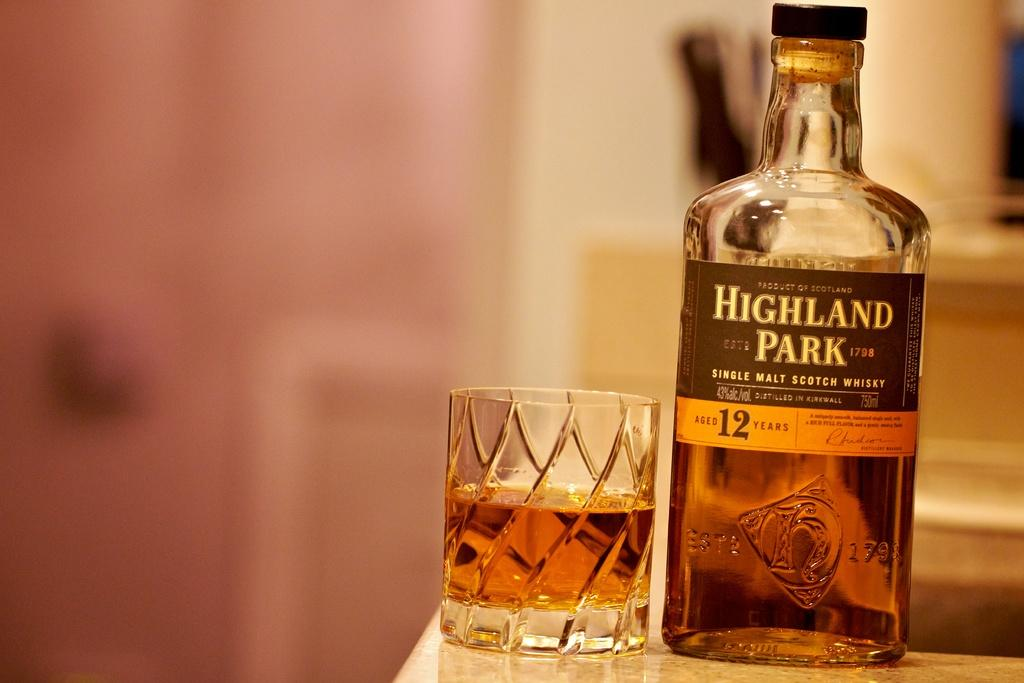<image>
Summarize the visual content of the image. A bottle of "Highland Park" whisky with the half full highball glass beside it. 